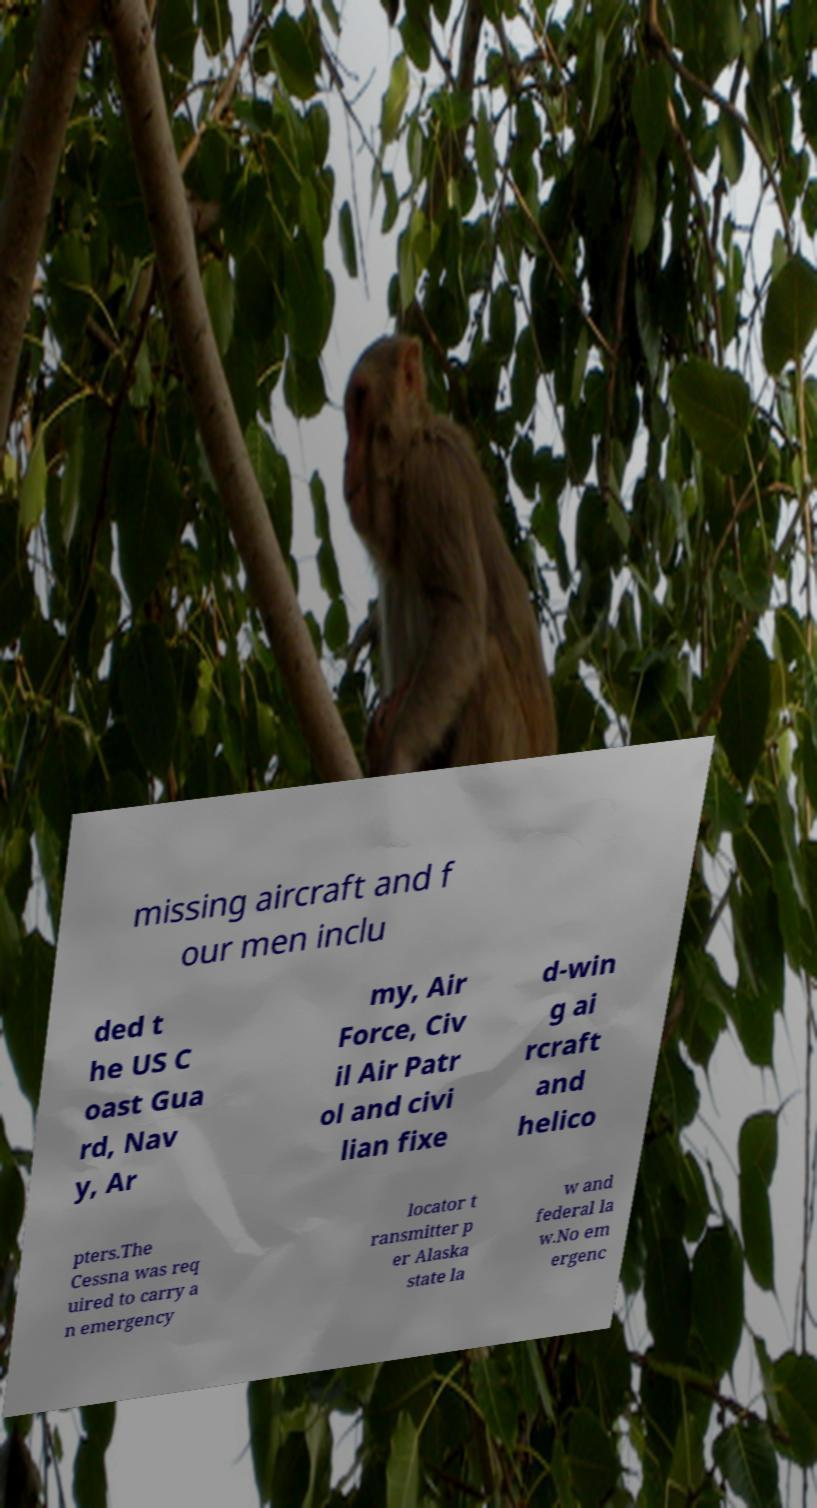Could you assist in decoding the text presented in this image and type it out clearly? missing aircraft and f our men inclu ded t he US C oast Gua rd, Nav y, Ar my, Air Force, Civ il Air Patr ol and civi lian fixe d-win g ai rcraft and helico pters.The Cessna was req uired to carry a n emergency locator t ransmitter p er Alaska state la w and federal la w.No em ergenc 